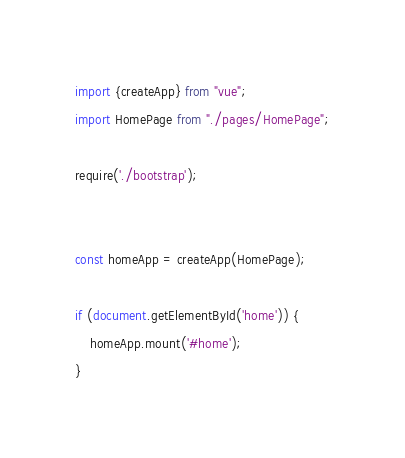<code> <loc_0><loc_0><loc_500><loc_500><_JavaScript_>import {createApp} from "vue";
import HomePage from "./pages/HomePage";

require('./bootstrap');


const homeApp = createApp(HomePage);

if (document.getElementById('home')) {
    homeApp.mount('#home');
}
</code> 